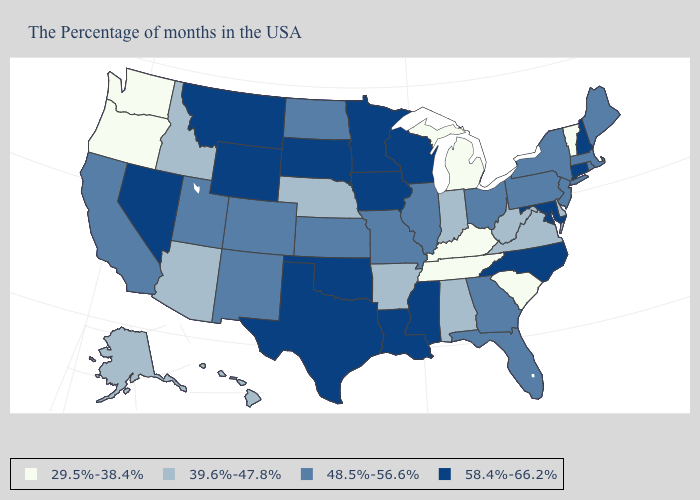Does the map have missing data?
Write a very short answer. No. What is the value of Kentucky?
Answer briefly. 29.5%-38.4%. Does New Hampshire have a higher value than Idaho?
Be succinct. Yes. What is the value of Utah?
Give a very brief answer. 48.5%-56.6%. Does North Carolina have the lowest value in the USA?
Be succinct. No. Does the first symbol in the legend represent the smallest category?
Give a very brief answer. Yes. Does California have the same value as Wyoming?
Give a very brief answer. No. Name the states that have a value in the range 48.5%-56.6%?
Keep it brief. Maine, Massachusetts, Rhode Island, New York, New Jersey, Pennsylvania, Ohio, Florida, Georgia, Illinois, Missouri, Kansas, North Dakota, Colorado, New Mexico, Utah, California. What is the highest value in the Northeast ?
Keep it brief. 58.4%-66.2%. Among the states that border Nebraska , does South Dakota have the highest value?
Answer briefly. Yes. Does Montana have the same value as Hawaii?
Give a very brief answer. No. Among the states that border Tennessee , does Mississippi have the highest value?
Short answer required. Yes. Does Texas have the highest value in the USA?
Quick response, please. Yes. Name the states that have a value in the range 39.6%-47.8%?
Keep it brief. Delaware, Virginia, West Virginia, Indiana, Alabama, Arkansas, Nebraska, Arizona, Idaho, Alaska, Hawaii. Among the states that border Oklahoma , does Arkansas have the lowest value?
Keep it brief. Yes. 